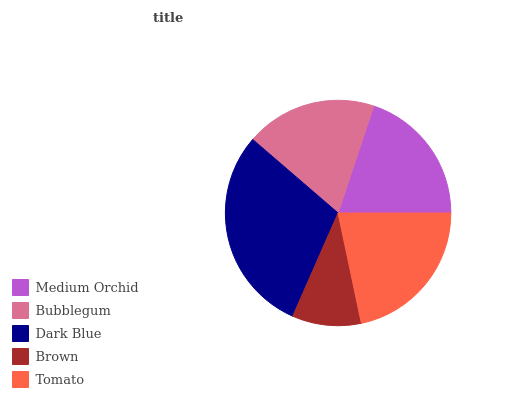Is Brown the minimum?
Answer yes or no. Yes. Is Dark Blue the maximum?
Answer yes or no. Yes. Is Bubblegum the minimum?
Answer yes or no. No. Is Bubblegum the maximum?
Answer yes or no. No. Is Medium Orchid greater than Bubblegum?
Answer yes or no. Yes. Is Bubblegum less than Medium Orchid?
Answer yes or no. Yes. Is Bubblegum greater than Medium Orchid?
Answer yes or no. No. Is Medium Orchid less than Bubblegum?
Answer yes or no. No. Is Medium Orchid the high median?
Answer yes or no. Yes. Is Medium Orchid the low median?
Answer yes or no. Yes. Is Bubblegum the high median?
Answer yes or no. No. Is Bubblegum the low median?
Answer yes or no. No. 